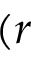Convert formula to latex. <formula><loc_0><loc_0><loc_500><loc_500>( r</formula> 